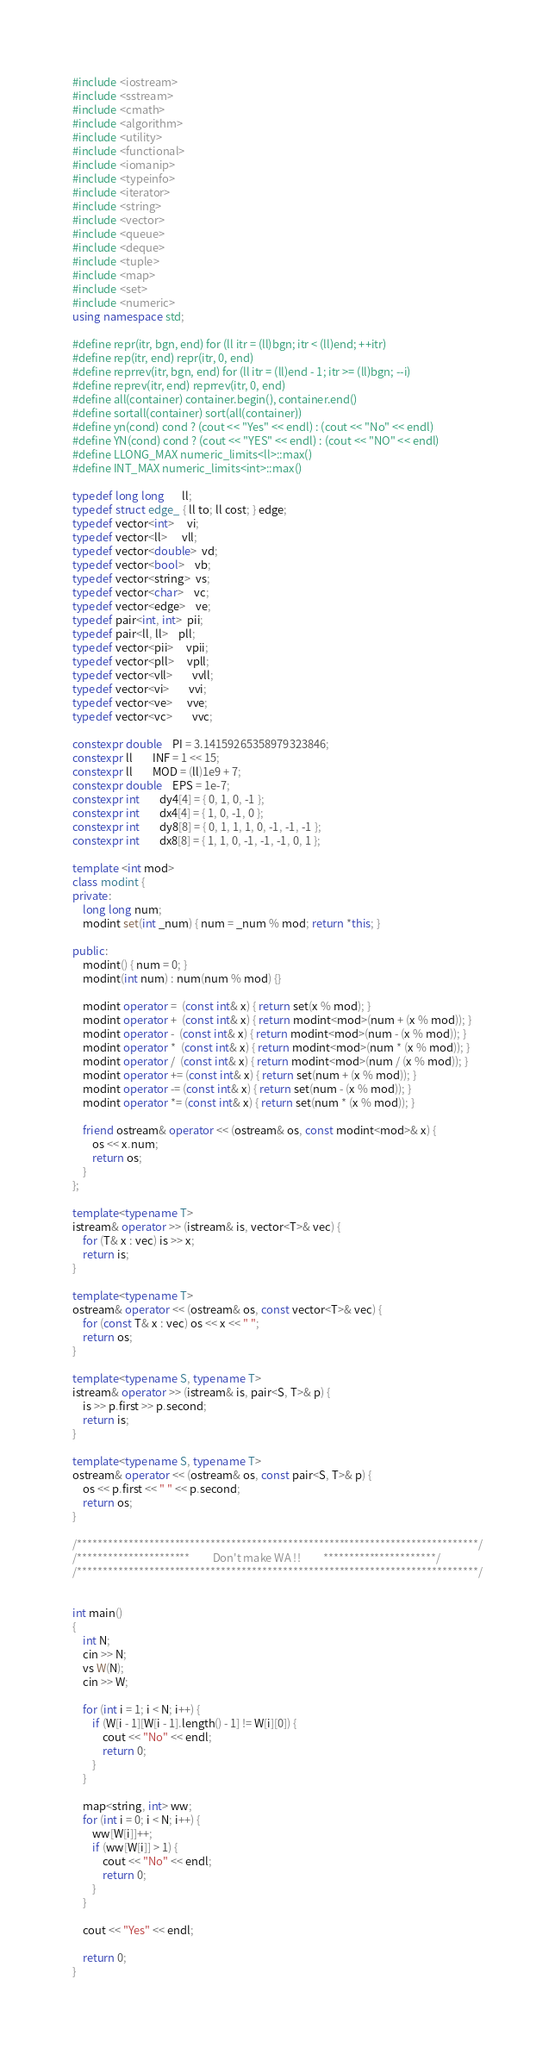<code> <loc_0><loc_0><loc_500><loc_500><_C++_>#include <iostream>
#include <sstream>
#include <cmath>
#include <algorithm>
#include <utility>
#include <functional>
#include <iomanip>
#include <typeinfo>
#include <iterator>
#include <string>
#include <vector>
#include <queue>
#include <deque>
#include <tuple>
#include <map>
#include <set>
#include <numeric>
using namespace std;

#define repr(itr, bgn, end) for (ll itr = (ll)bgn; itr < (ll)end; ++itr)
#define rep(itr, end) repr(itr, 0, end)
#define reprrev(itr, bgn, end) for (ll itr = (ll)end - 1; itr >= (ll)bgn; --i)
#define reprev(itr, end) reprrev(itr, 0, end)
#define all(container) container.begin(), container.end()
#define sortall(container) sort(all(container))
#define yn(cond) cond ? (cout << "Yes" << endl) : (cout << "No" << endl)
#define YN(cond) cond ? (cout << "YES" << endl) : (cout << "NO" << endl)
#define LLONG_MAX numeric_limits<ll>::max()
#define INT_MAX numeric_limits<int>::max()

typedef long long       ll;
typedef struct edge_ { ll to; ll cost; } edge;
typedef vector<int>     vi;
typedef vector<ll>      vll;
typedef vector<double>  vd;
typedef vector<bool>    vb;
typedef vector<string>  vs;
typedef vector<char>    vc;
typedef vector<edge>    ve;
typedef pair<int, int>  pii;
typedef pair<ll, ll>    pll;
typedef vector<pii>     vpii;
typedef vector<pll>     vpll;
typedef vector<vll>		vvll;
typedef vector<vi>		vvi;
typedef vector<ve>      vve;
typedef vector<vc>		vvc;

constexpr double	PI = 3.14159265358979323846;
constexpr ll		INF = 1 << 15;
constexpr ll		MOD = (ll)1e9 + 7;
constexpr double	EPS = 1e-7;
constexpr int		dy4[4] = { 0, 1, 0, -1 };
constexpr int		dx4[4] = { 1, 0, -1, 0 };
constexpr int		dy8[8] = { 0, 1, 1, 1, 0, -1, -1, -1 };
constexpr int		dx8[8] = { 1, 1, 0, -1, -1, -1, 0, 1 };

template <int mod>
class modint {
private:
	long long num;
	modint set(int _num) { num = _num % mod; return *this; }

public:
	modint() { num = 0; }
	modint(int num) : num(num % mod) {}

	modint operator =  (const int& x) { return set(x % mod); }
	modint operator +  (const int& x) { return modint<mod>(num + (x % mod)); }
	modint operator -  (const int& x) { return modint<mod>(num - (x % mod)); }
	modint operator *  (const int& x) { return modint<mod>(num * (x % mod)); }
	modint operator /  (const int& x) { return modint<mod>(num / (x % mod)); }
	modint operator += (const int& x) { return set(num + (x % mod)); }
	modint operator -= (const int& x) { return set(num - (x % mod)); }
	modint operator *= (const int& x) { return set(num * (x % mod)); }

	friend ostream& operator << (ostream& os, const modint<mod>& x) {
		os << x.num;
		return os;
	}
};

template<typename T>
istream& operator >> (istream& is, vector<T>& vec) {
	for (T& x : vec) is >> x;
	return is;
}

template<typename T>
ostream& operator << (ostream& os, const vector<T>& vec) {
	for (const T& x : vec) os << x << " ";
	return os;
}

template<typename S, typename T>
istream& operator >> (istream& is, pair<S, T>& p) {
	is >> p.first >> p.second;
	return is;
}

template<typename S, typename T>
ostream& operator << (ostream& os, const pair<S, T>& p) {
	os << p.first << " " << p.second;
	return os;
}

/******************************************************************************/
/**********************         Don't make WA !!         **********************/
/******************************************************************************/


int main()
{
	int N;
	cin >> N;
	vs W(N);
	cin >> W;

	for (int i = 1; i < N; i++) {
		if (W[i - 1][W[i - 1].length() - 1] != W[i][0]) {
			cout << "No" << endl;
			return 0;
		}
	}

	map<string, int> ww;
	for (int i = 0; i < N; i++) {
		ww[W[i]]++;
		if (ww[W[i]] > 1) {
			cout << "No" << endl;
			return 0;
		}
	}

	cout << "Yes" << endl;

	return 0;
}</code> 